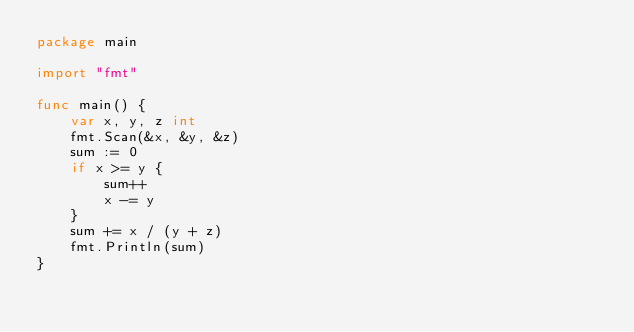<code> <loc_0><loc_0><loc_500><loc_500><_Go_>package main

import "fmt"

func main() {
	var x, y, z int
	fmt.Scan(&x, &y, &z)
	sum := 0
	if x >= y {
		sum++
		x -= y
	}
	sum += x / (y + z)
	fmt.Println(sum)
}
</code> 